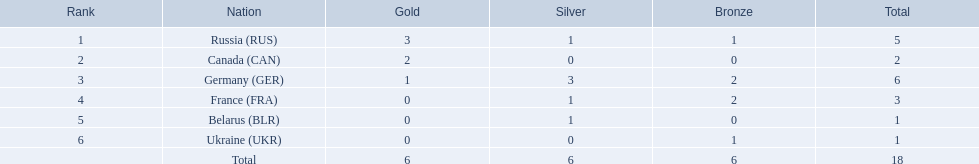Which countries had one or more gold medals? Russia (RUS), Canada (CAN), Germany (GER). Of these countries, which had at least one silver medal? Russia (RUS), Germany (GER). Of the remaining countries, who had more medals overall? Germany (GER). 